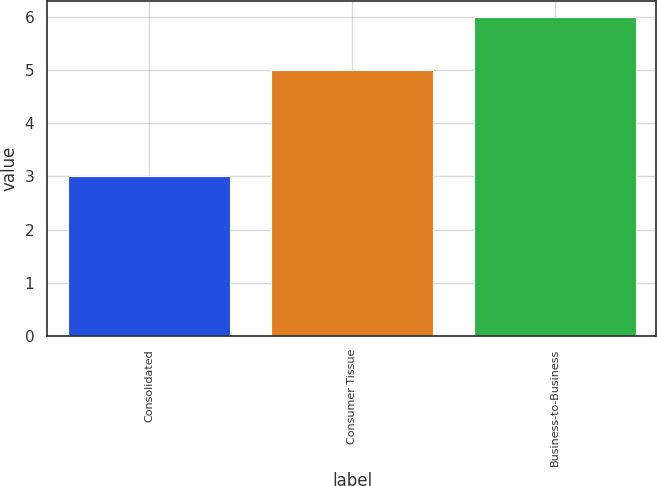Convert chart. <chart><loc_0><loc_0><loc_500><loc_500><bar_chart><fcel>Consolidated<fcel>Consumer Tissue<fcel>Business-to-Business<nl><fcel>3<fcel>5<fcel>6<nl></chart> 